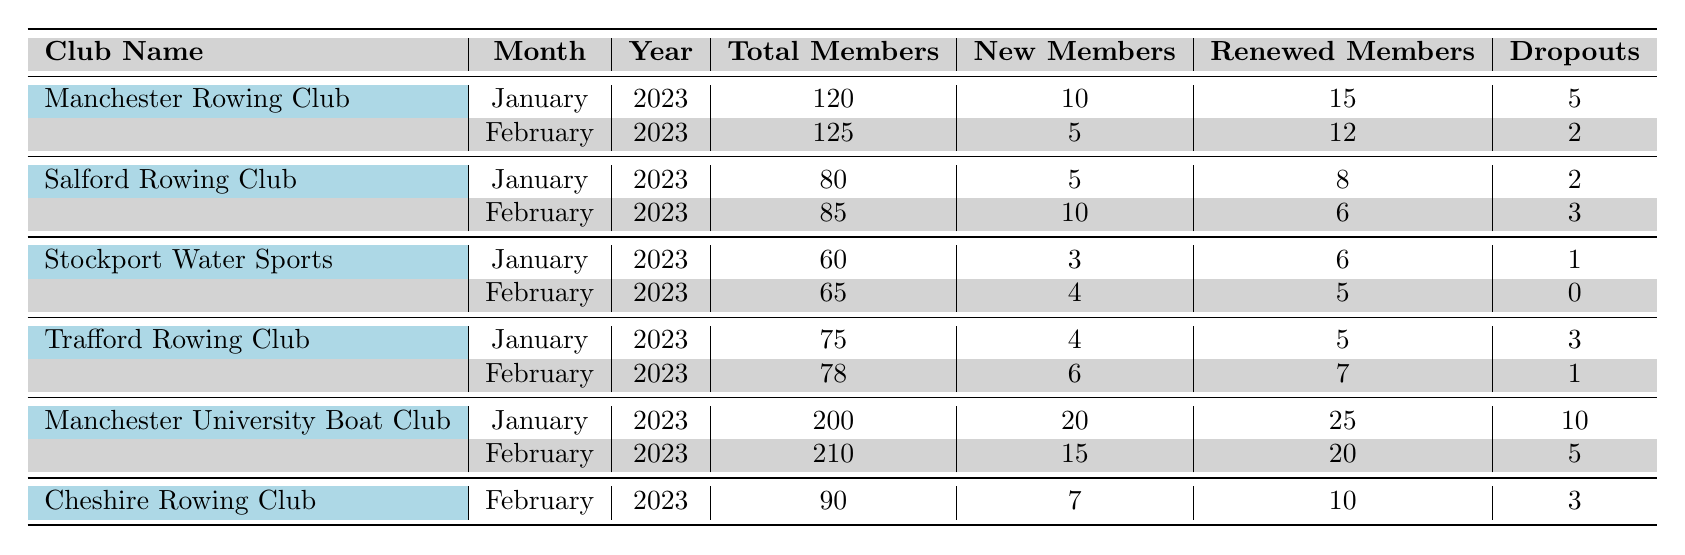What was the total number of members in Manchester University Boat Club in January 2023? According to the table, the total members in Manchester University Boat Club for January 2023 is directly listed. The value is 200.
Answer: 200 How many new members joined Salford Rowing Club in February 2023? The new members for Salford Rowing Club in February 2023 is explicitly mentioned in the table. It shows a value of 10 new members.
Answer: 10 What is the total number of dropouts for Stockport Water Sports from January to February 2023? For Stockport Water Sports, the dropouts in January are 1, and in February are 0. Adding these two values together gives 1 + 0 = 1.
Answer: 1 Which club had the highest total members in February 2023? In February 2023, Manchester University Boat Club has 210 members, which is higher than all other listed clubs.
Answer: Manchester University Boat Club How many more total members did Manchester Rowing Club have in February compared to January 2023? Manchester Rowing Club had 125 members in February and 120 members in January. The difference is calculated as 125 - 120 = 5.
Answer: 5 What percentage of members renewed their membership in Trafford Rowing Club in January 2023? Trafford Rowing Club had 75 total members and 5 renewed members in January. To find the percentage, (5/75) * 100 = 6.67%.
Answer: 6.67% Did Cheshire Rowing Club experience an increase in total membership from January to February 2023? The table shows that Cheshire Rowing Club has no entry for January, so there isn't enough data to determine a change in membership for that timeframe.
Answer: No What is the overall average number of new members across all clubs for January 2023? The new members for January across the clubs are: 10 (Manchester) + 5 (Salford) + 3 (Stockport) + 4 (Trafford) + 20 (Manchester Uni) = 42. There are 5 clubs, so the average is 42/5 = 8.4.
Answer: 8.4 How many total members does Trafford Rowing Club have across both months? Trafford Rowing Club has 75 members in January and 78 members in February. Adding these numbers gives 75 + 78 = 153.
Answer: 153 Was there a decrease in total members for any club from January to February 2023? The table indicates that Stockport Water Sports increased from 60 to 65 members, Salford had an increase as well. Trafford increased from 75 to 78 members, while Manchester Rowing Club also went up from 120 to 125. Therefore, no club decreased in membership.
Answer: No 